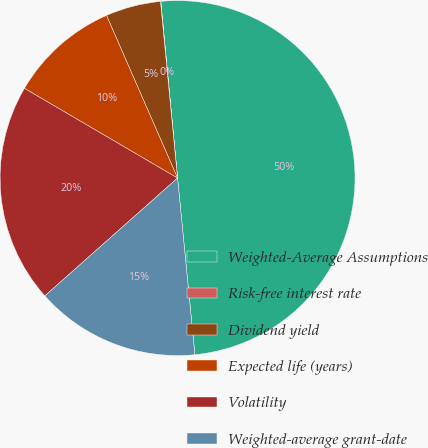<chart> <loc_0><loc_0><loc_500><loc_500><pie_chart><fcel>Weighted-Average Assumptions<fcel>Risk-free interest rate<fcel>Dividend yield<fcel>Expected life (years)<fcel>Volatility<fcel>Weighted-average grant-date<nl><fcel>49.94%<fcel>0.03%<fcel>5.02%<fcel>10.01%<fcel>19.99%<fcel>15.0%<nl></chart> 